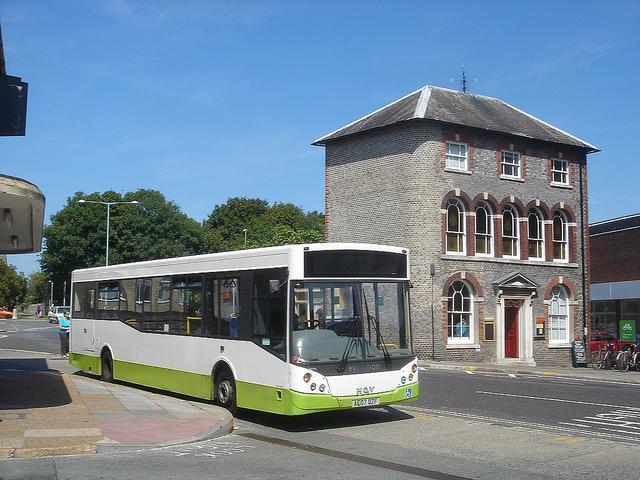How many bus do you see?
Give a very brief answer. 1. How many green ties are there?
Give a very brief answer. 0. 